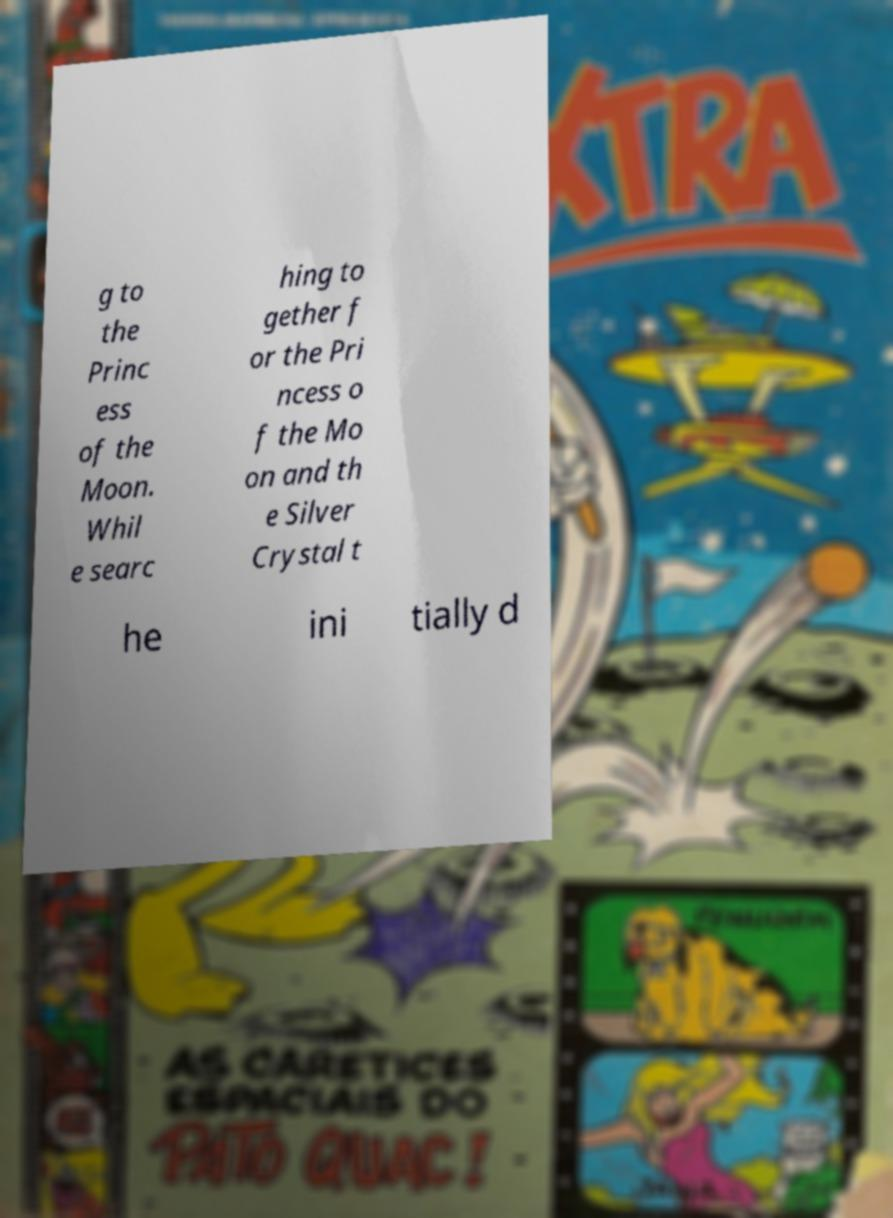Can you read and provide the text displayed in the image?This photo seems to have some interesting text. Can you extract and type it out for me? g to the Princ ess of the Moon. Whil e searc hing to gether f or the Pri ncess o f the Mo on and th e Silver Crystal t he ini tially d 